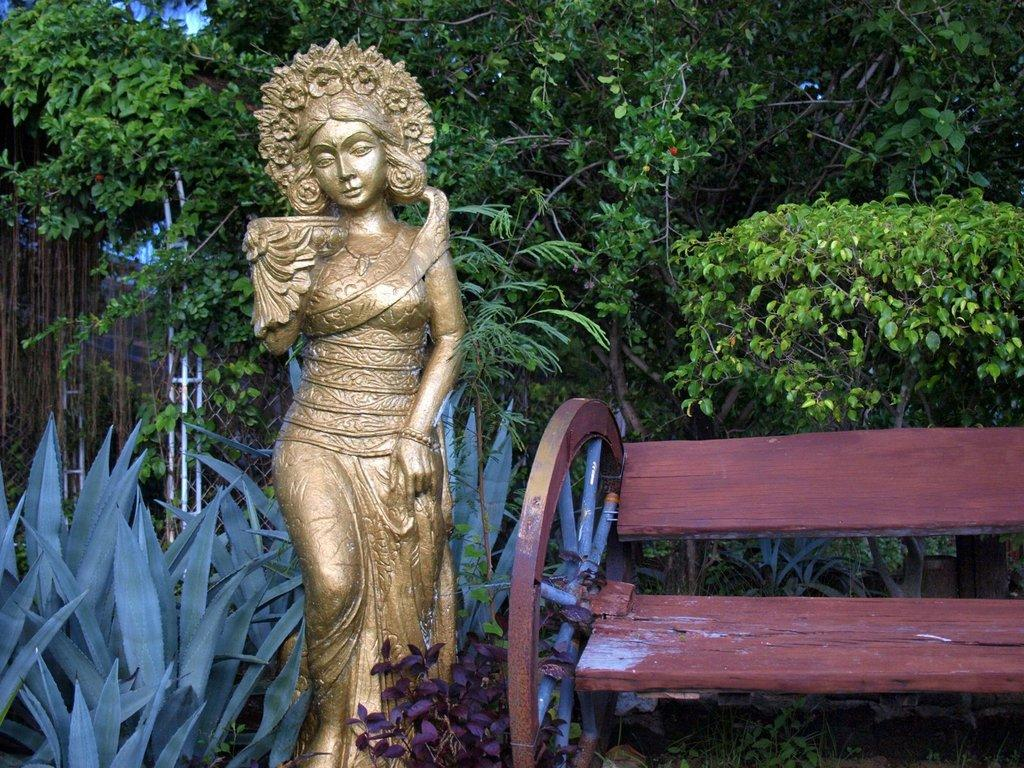Where was the image taken? The image was taken in a garden. What is the main object in the front of the image? There is an idol in golden color in the front of the image. What is located to the right of the idol? There is a wooden bench to the right of the idol. What can be seen in the background of the image? There are trees and plants in the background of the image. What type of brush is being used to clean the idol in the image? There is no brush visible in the image, and the idol is not being cleaned. 